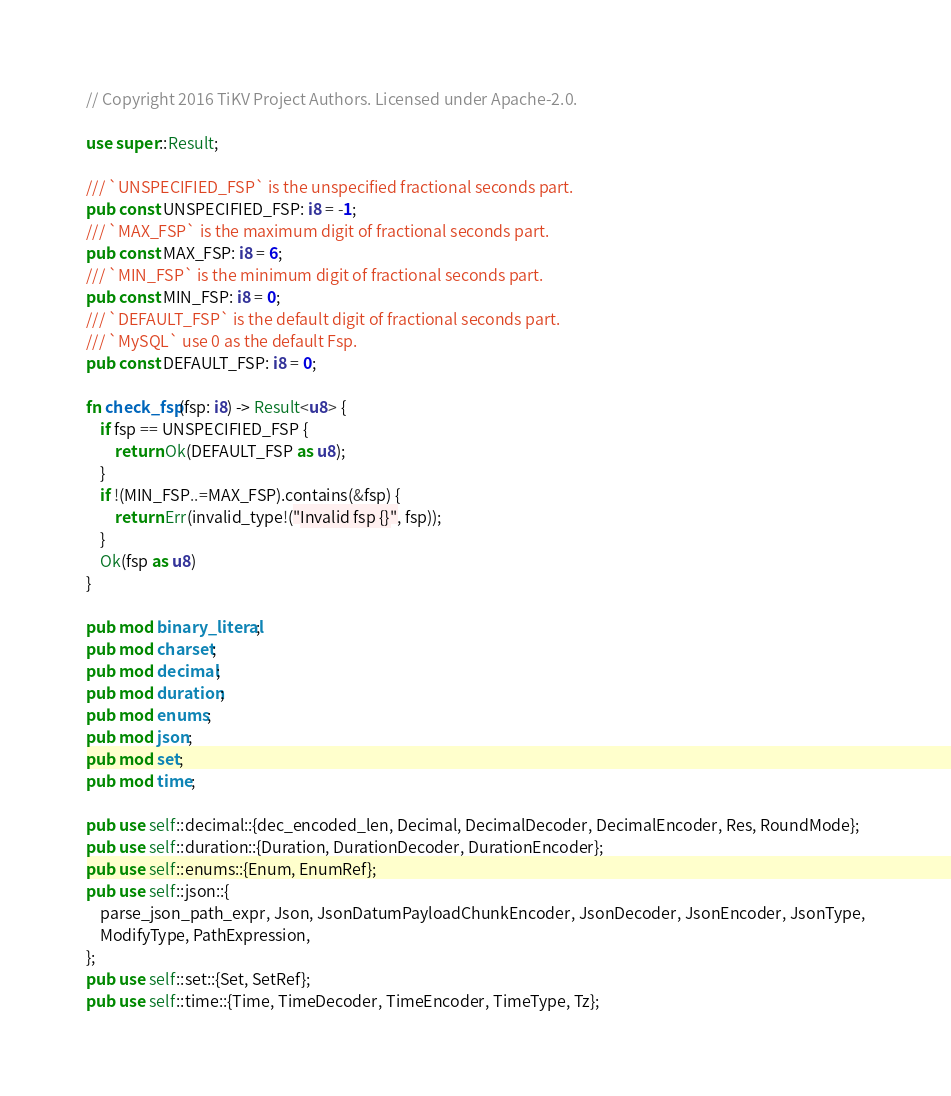<code> <loc_0><loc_0><loc_500><loc_500><_Rust_>// Copyright 2016 TiKV Project Authors. Licensed under Apache-2.0.

use super::Result;

/// `UNSPECIFIED_FSP` is the unspecified fractional seconds part.
pub const UNSPECIFIED_FSP: i8 = -1;
/// `MAX_FSP` is the maximum digit of fractional seconds part.
pub const MAX_FSP: i8 = 6;
/// `MIN_FSP` is the minimum digit of fractional seconds part.
pub const MIN_FSP: i8 = 0;
/// `DEFAULT_FSP` is the default digit of fractional seconds part.
/// `MySQL` use 0 as the default Fsp.
pub const DEFAULT_FSP: i8 = 0;

fn check_fsp(fsp: i8) -> Result<u8> {
    if fsp == UNSPECIFIED_FSP {
        return Ok(DEFAULT_FSP as u8);
    }
    if !(MIN_FSP..=MAX_FSP).contains(&fsp) {
        return Err(invalid_type!("Invalid fsp {}", fsp));
    }
    Ok(fsp as u8)
}

pub mod binary_literal;
pub mod charset;
pub mod decimal;
pub mod duration;
pub mod enums;
pub mod json;
pub mod set;
pub mod time;

pub use self::decimal::{dec_encoded_len, Decimal, DecimalDecoder, DecimalEncoder, Res, RoundMode};
pub use self::duration::{Duration, DurationDecoder, DurationEncoder};
pub use self::enums::{Enum, EnumRef};
pub use self::json::{
    parse_json_path_expr, Json, JsonDatumPayloadChunkEncoder, JsonDecoder, JsonEncoder, JsonType,
    ModifyType, PathExpression,
};
pub use self::set::{Set, SetRef};
pub use self::time::{Time, TimeDecoder, TimeEncoder, TimeType, Tz};
</code> 